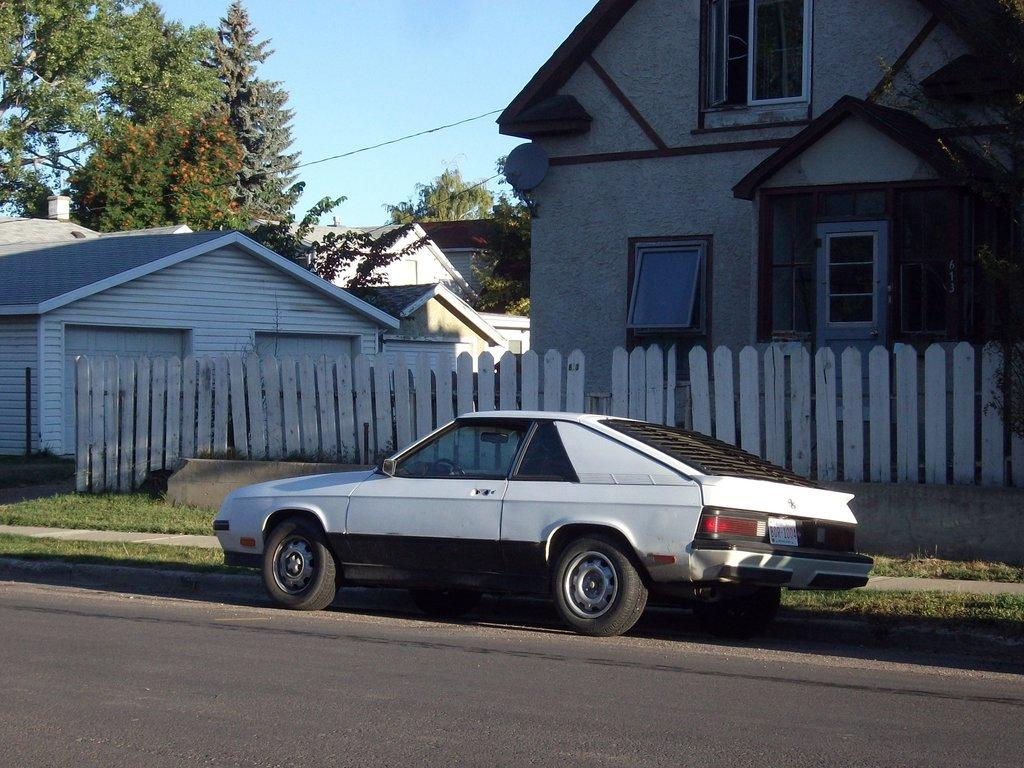What type of vehicle is in the image? The facts do not specify the type of vehicle, but there is a vehicle present in the image. What is the purpose of the fencing in the image? The purpose of the fencing is not mentioned in the facts, but there is fencing visible in the image. What type of structures can be seen in the image? There are buildings in the image. What feature can be seen on the buildings? There are glass windows on the buildings. What other objects can be seen in the image? There is wire and trees visible in the image. What is the color of the sky in the image? The sky is blue in color. Can you tell me how many quinces are hanging from the trees in the image? There is no mention of quinces in the image, so it is impossible to determine how many there are. Is the son of the person who took the photo visible in the image? There is no information about the person who took the photo or their son, so it cannot be determined if the son is visible in the image. 